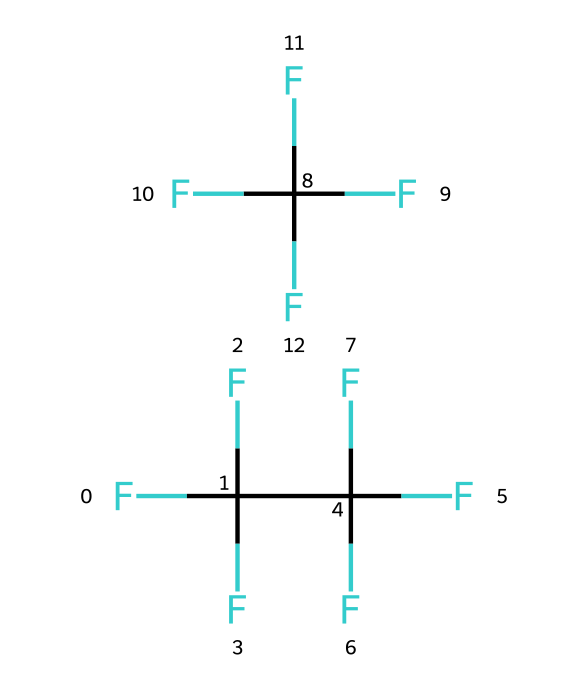How many carbon atoms are in R-410A? R-410A consists of two distinct components, and each component contains a specific number of carbon atoms. The first component, FC(F)(F)C(F)(F)F, has 2 carbon atoms, while the second component, C(F)(F)(F)F, has 1 carbon atom. Therefore, the total number of carbon atoms is 2 + 1 = 3.
Answer: 3 What is the total number of fluorine atoms in R-410A? The first component has 5 fluorine atoms (FC(F)(F)C(F)(F)F), and the second component has 4 fluorine atoms (C(F)(F)(F)F). Adding them together gives a total of 5 + 4 = 9 fluorine atoms in R-410A.
Answer: 9 How many distinct components are in the R-410A blend? The chemical structure shows two separate parts (FC(F)(F)C(F)(F)F and C(F)(F)(F)F), indicating that R-410A is a blend of two distinct refrigerants.
Answer: 2 Is R-410A a single or blended refrigerant? The presence of two separate parts in the SMILES representation indicates that R-410A is a blended refrigerant rather than a single compound.
Answer: blended What functional groups can be identified in R-410A based on its structure? R-410A does not exhibit typical functional groups like alcohols or amines; instead, it is made up primarily of carbon and fluorine, which are indicative of halogenated compounds. This indicates it mainly follows the structure of halocarbons, common in refrigerants.
Answer: halocarbon What is the primary use of R-410A? R-410A is commonly used in residential air conditioning systems and heat pumps due to its efficiency and environmental compliance.
Answer: air conditioning 